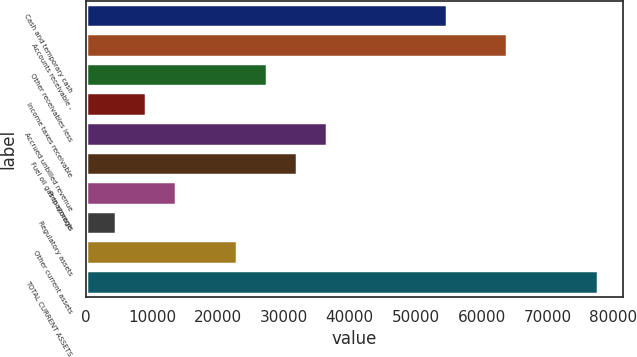Convert chart. <chart><loc_0><loc_0><loc_500><loc_500><bar_chart><fcel>Cash and temporary cash<fcel>Accounts receivable -<fcel>Other receivables less<fcel>Income taxes receivable<fcel>Accrued unbilled revenue<fcel>Fuel oil gas in storage<fcel>Prepayments<fcel>Regulatory assets<fcel>Other current assets<fcel>TOTAL CURRENT ASSETS<nl><fcel>54770<fcel>63898<fcel>27386<fcel>9130<fcel>36514<fcel>31950<fcel>13694<fcel>4566<fcel>22822<fcel>77590<nl></chart> 